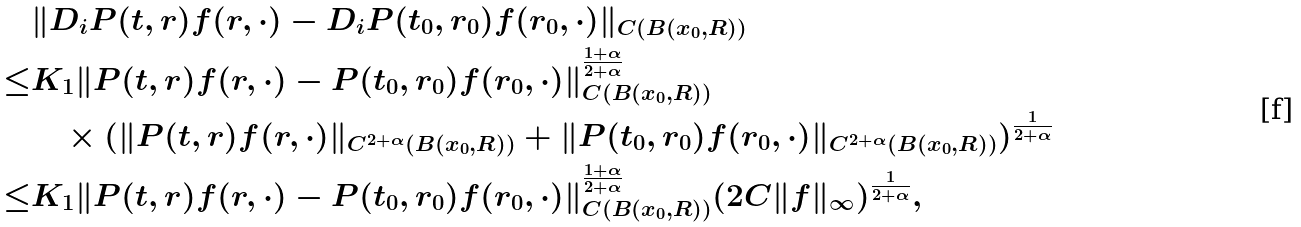<formula> <loc_0><loc_0><loc_500><loc_500>& \| D _ { i } P ( t , r ) f ( r , \cdot ) - D _ { i } P ( t _ { 0 } , r _ { 0 } ) f ( r _ { 0 } , \cdot ) \| _ { C ( B ( x _ { 0 } , R ) ) } \\ \leq & K _ { 1 } \| P ( t , r ) f ( r , \cdot ) - P ( t _ { 0 } , r _ { 0 } ) f ( r _ { 0 } , \cdot ) \| _ { C ( B ( x _ { 0 } , R ) ) } ^ { \frac { 1 + \alpha } { 2 + \alpha } } \\ & \quad \times ( \| P ( t , r ) f ( r , \cdot ) \| _ { C ^ { 2 + \alpha } ( B ( x _ { 0 } , R ) ) } + \| P ( t _ { 0 } , r _ { 0 } ) f ( r _ { 0 } , \cdot ) \| _ { C ^ { 2 + \alpha } ( B ( x _ { 0 } , R ) ) } ) ^ { \frac { 1 } { 2 + \alpha } } \\ \leq & K _ { 1 } \| P ( t , r ) f ( r , \cdot ) - P ( t _ { 0 } , r _ { 0 } ) f ( r _ { 0 } , \cdot ) \| _ { C ( B ( x _ { 0 } , R ) ) } ^ { \frac { 1 + \alpha } { 2 + \alpha } } ( 2 C \| f \| _ { \infty } ) ^ { \frac { 1 } { 2 + \alpha } } ,</formula> 